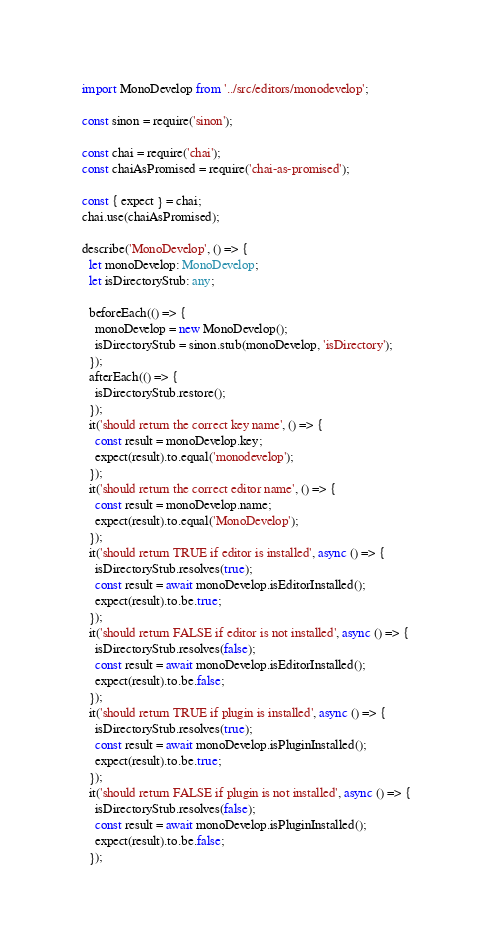Convert code to text. <code><loc_0><loc_0><loc_500><loc_500><_TypeScript_>import MonoDevelop from '../src/editors/monodevelop';

const sinon = require('sinon');

const chai = require('chai');
const chaiAsPromised = require('chai-as-promised');

const { expect } = chai;
chai.use(chaiAsPromised);

describe('MonoDevelop', () => {
  let monoDevelop: MonoDevelop;
  let isDirectoryStub: any;

  beforeEach(() => {
    monoDevelop = new MonoDevelop();
    isDirectoryStub = sinon.stub(monoDevelop, 'isDirectory');
  });
  afterEach(() => {
    isDirectoryStub.restore();
  });
  it('should return the correct key name', () => {
    const result = monoDevelop.key;
    expect(result).to.equal('monodevelop');
  });
  it('should return the correct editor name', () => {
    const result = monoDevelop.name;
    expect(result).to.equal('MonoDevelop');
  });
  it('should return TRUE if editor is installed', async () => {
    isDirectoryStub.resolves(true);
    const result = await monoDevelop.isEditorInstalled();
    expect(result).to.be.true;
  });
  it('should return FALSE if editor is not installed', async () => {
    isDirectoryStub.resolves(false);
    const result = await monoDevelop.isEditorInstalled();
    expect(result).to.be.false;
  });
  it('should return TRUE if plugin is installed', async () => {
    isDirectoryStub.resolves(true);
    const result = await monoDevelop.isPluginInstalled();
    expect(result).to.be.true;
  });
  it('should return FALSE if plugin is not installed', async () => {
    isDirectoryStub.resolves(false);
    const result = await monoDevelop.isPluginInstalled();
    expect(result).to.be.false;
  });</code> 